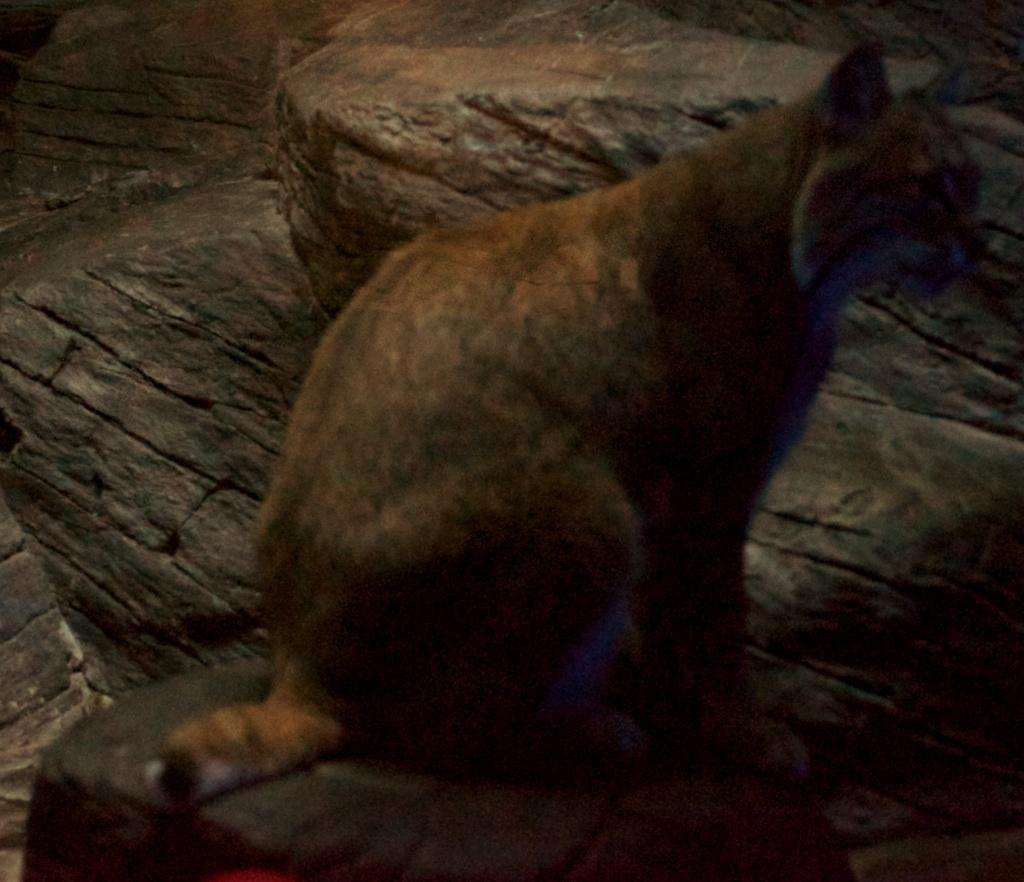What type of animal is in the image? The type of animal cannot be determined from the provided facts. What can be seen in the background of the image? There are rocks in the background of the image. What type of harmony is being played by the animal in the image? There is no indication of any music or harmony in the image, as it features an animal and rocks in the background. 